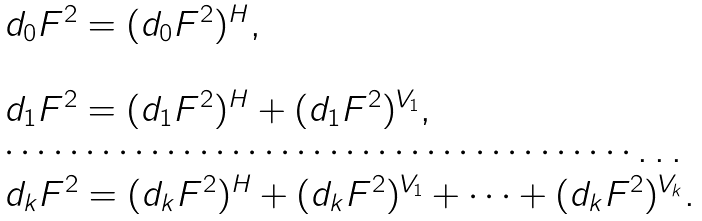<formula> <loc_0><loc_0><loc_500><loc_500>\begin{array} { l } d _ { 0 } F ^ { 2 } = ( d _ { 0 } F ^ { 2 } ) ^ { H } , \\ \\ d _ { 1 } F ^ { 2 } = ( d _ { 1 } F ^ { 2 } ) ^ { H } + ( d _ { 1 } F ^ { 2 } ) ^ { V _ { 1 } } , \\ \cdots \cdots \cdots \cdots \cdots \cdots \cdots \cdots \cdots \cdots \cdots \cdots \cdots \dots \\ d _ { k } F ^ { 2 } = ( d _ { k } F ^ { 2 } ) ^ { H } + ( d _ { k } F ^ { 2 } ) ^ { V _ { 1 } } + \dots + ( d _ { k } F ^ { 2 } ) ^ { V _ { k } } . \end{array}</formula> 